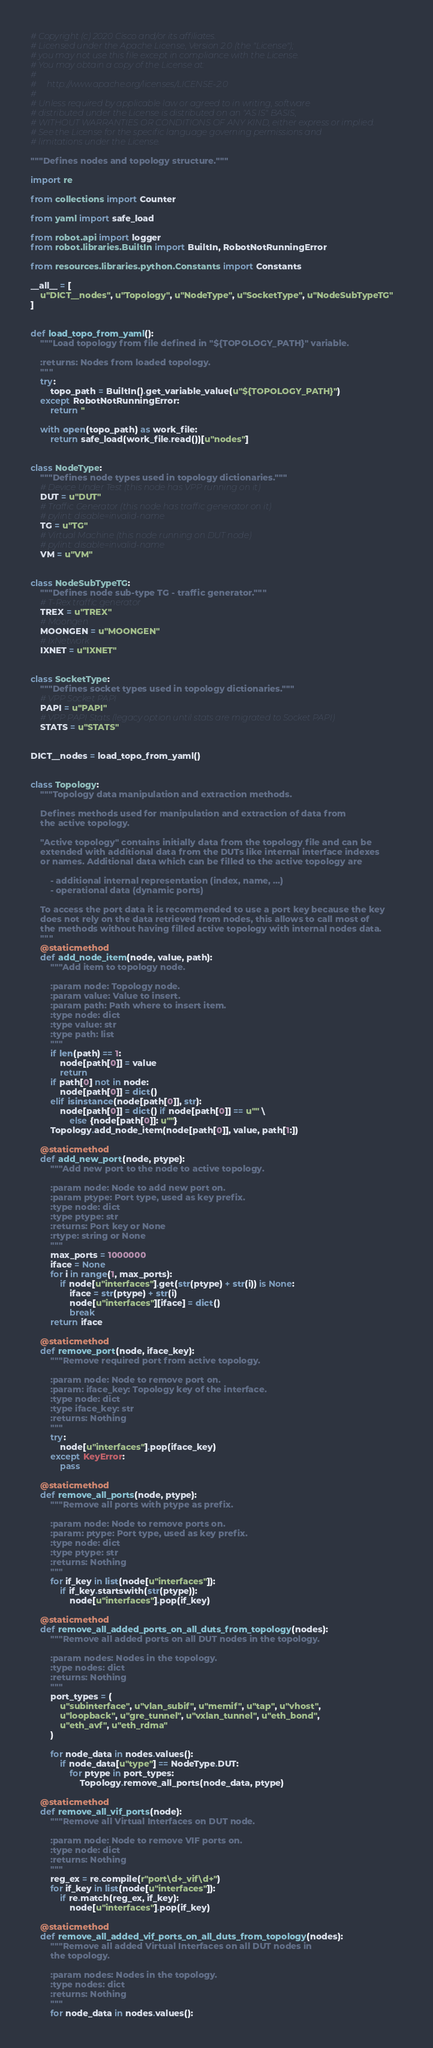<code> <loc_0><loc_0><loc_500><loc_500><_Python_># Copyright (c) 2020 Cisco and/or its affiliates.
# Licensed under the Apache License, Version 2.0 (the "License");
# you may not use this file except in compliance with the License.
# You may obtain a copy of the License at:
#
#     http://www.apache.org/licenses/LICENSE-2.0
#
# Unless required by applicable law or agreed to in writing, software
# distributed under the License is distributed on an "AS IS" BASIS,
# WITHOUT WARRANTIES OR CONDITIONS OF ANY KIND, either express or implied.
# See the License for the specific language governing permissions and
# limitations under the License.

"""Defines nodes and topology structure."""

import re

from collections import Counter

from yaml import safe_load

from robot.api import logger
from robot.libraries.BuiltIn import BuiltIn, RobotNotRunningError

from resources.libraries.python.Constants import Constants

__all__ = [
    u"DICT__nodes", u"Topology", u"NodeType", u"SocketType", u"NodeSubTypeTG"
]


def load_topo_from_yaml():
    """Load topology from file defined in "${TOPOLOGY_PATH}" variable.

    :returns: Nodes from loaded topology.
    """
    try:
        topo_path = BuiltIn().get_variable_value(u"${TOPOLOGY_PATH}")
    except RobotNotRunningError:
        return ''

    with open(topo_path) as work_file:
        return safe_load(work_file.read())[u"nodes"]


class NodeType:
    """Defines node types used in topology dictionaries."""
    # Device Under Test (this node has VPP running on it)
    DUT = u"DUT"
    # Traffic Generator (this node has traffic generator on it)
    # pylint: disable=invalid-name
    TG = u"TG"
    # Virtual Machine (this node running on DUT node)
    # pylint: disable=invalid-name
    VM = u"VM"


class NodeSubTypeTG:
    """Defines node sub-type TG - traffic generator."""
    # T-Rex traffic generator
    TREX = u"TREX"
    # Moongen
    MOONGEN = u"MOONGEN"
    # IxNetwork
    IXNET = u"IXNET"


class SocketType:
    """Defines socket types used in topology dictionaries."""
    # VPP Socket PAPI
    PAPI = u"PAPI"
    # VPP PAPI Stats (legacy option until stats are migrated to Socket PAPI)
    STATS = u"STATS"


DICT__nodes = load_topo_from_yaml()


class Topology:
    """Topology data manipulation and extraction methods.

    Defines methods used for manipulation and extraction of data from
    the active topology.

    "Active topology" contains initially data from the topology file and can be
    extended with additional data from the DUTs like internal interface indexes
    or names. Additional data which can be filled to the active topology are

        - additional internal representation (index, name, ...)
        - operational data (dynamic ports)

    To access the port data it is recommended to use a port key because the key
    does not rely on the data retrieved from nodes, this allows to call most of
    the methods without having filled active topology with internal nodes data.
    """
    @staticmethod
    def add_node_item(node, value, path):
        """Add item to topology node.

        :param node: Topology node.
        :param value: Value to insert.
        :param path: Path where to insert item.
        :type node: dict
        :type value: str
        :type path: list
        """
        if len(path) == 1:
            node[path[0]] = value
            return
        if path[0] not in node:
            node[path[0]] = dict()
        elif isinstance(node[path[0]], str):
            node[path[0]] = dict() if node[path[0]] == u"" \
                else {node[path[0]]: u""}
        Topology.add_node_item(node[path[0]], value, path[1:])

    @staticmethod
    def add_new_port(node, ptype):
        """Add new port to the node to active topology.

        :param node: Node to add new port on.
        :param ptype: Port type, used as key prefix.
        :type node: dict
        :type ptype: str
        :returns: Port key or None
        :rtype: string or None
        """
        max_ports = 1000000
        iface = None
        for i in range(1, max_ports):
            if node[u"interfaces"].get(str(ptype) + str(i)) is None:
                iface = str(ptype) + str(i)
                node[u"interfaces"][iface] = dict()
                break
        return iface

    @staticmethod
    def remove_port(node, iface_key):
        """Remove required port from active topology.

        :param node: Node to remove port on.
        :param: iface_key: Topology key of the interface.
        :type node: dict
        :type iface_key: str
        :returns: Nothing
        """
        try:
            node[u"interfaces"].pop(iface_key)
        except KeyError:
            pass

    @staticmethod
    def remove_all_ports(node, ptype):
        """Remove all ports with ptype as prefix.

        :param node: Node to remove ports on.
        :param: ptype: Port type, used as key prefix.
        :type node: dict
        :type ptype: str
        :returns: Nothing
        """
        for if_key in list(node[u"interfaces"]):
            if if_key.startswith(str(ptype)):
                node[u"interfaces"].pop(if_key)

    @staticmethod
    def remove_all_added_ports_on_all_duts_from_topology(nodes):
        """Remove all added ports on all DUT nodes in the topology.

        :param nodes: Nodes in the topology.
        :type nodes: dict
        :returns: Nothing
        """
        port_types = (
            u"subinterface", u"vlan_subif", u"memif", u"tap", u"vhost",
            u"loopback", u"gre_tunnel", u"vxlan_tunnel", u"eth_bond",
            u"eth_avf", u"eth_rdma"
        )

        for node_data in nodes.values():
            if node_data[u"type"] == NodeType.DUT:
                for ptype in port_types:
                    Topology.remove_all_ports(node_data, ptype)

    @staticmethod
    def remove_all_vif_ports(node):
        """Remove all Virtual Interfaces on DUT node.

        :param node: Node to remove VIF ports on.
        :type node: dict
        :returns: Nothing
        """
        reg_ex = re.compile(r"port\d+_vif\d+")
        for if_key in list(node[u"interfaces"]):
            if re.match(reg_ex, if_key):
                node[u"interfaces"].pop(if_key)

    @staticmethod
    def remove_all_added_vif_ports_on_all_duts_from_topology(nodes):
        """Remove all added Virtual Interfaces on all DUT nodes in
        the topology.

        :param nodes: Nodes in the topology.
        :type nodes: dict
        :returns: Nothing
        """
        for node_data in nodes.values():</code> 